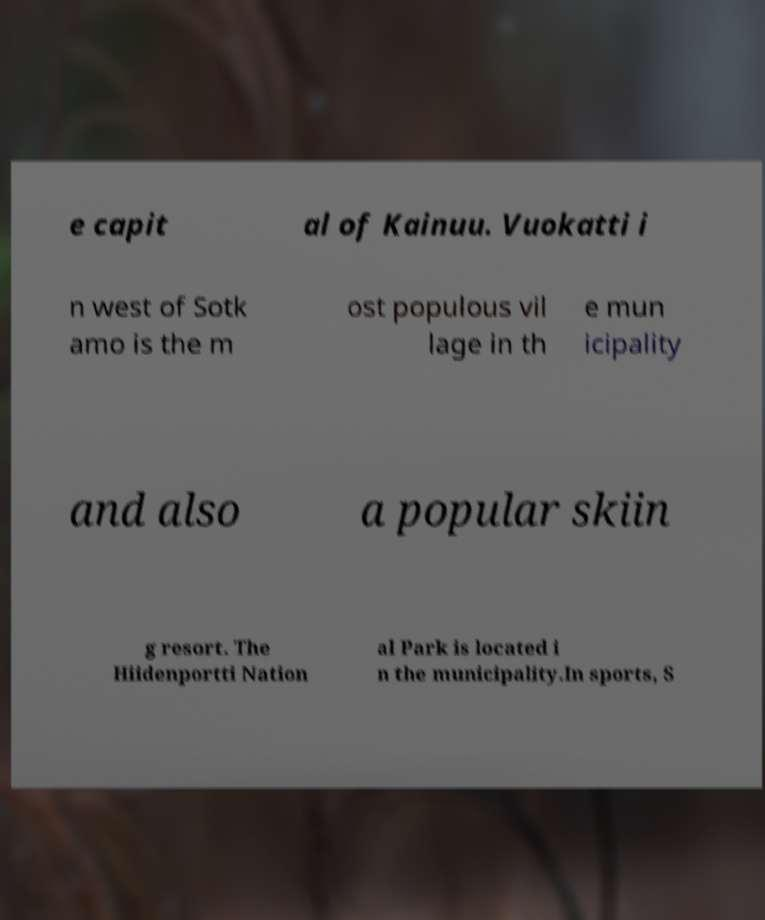Please read and relay the text visible in this image. What does it say? e capit al of Kainuu. Vuokatti i n west of Sotk amo is the m ost populous vil lage in th e mun icipality and also a popular skiin g resort. The Hiidenportti Nation al Park is located i n the municipality.In sports, S 